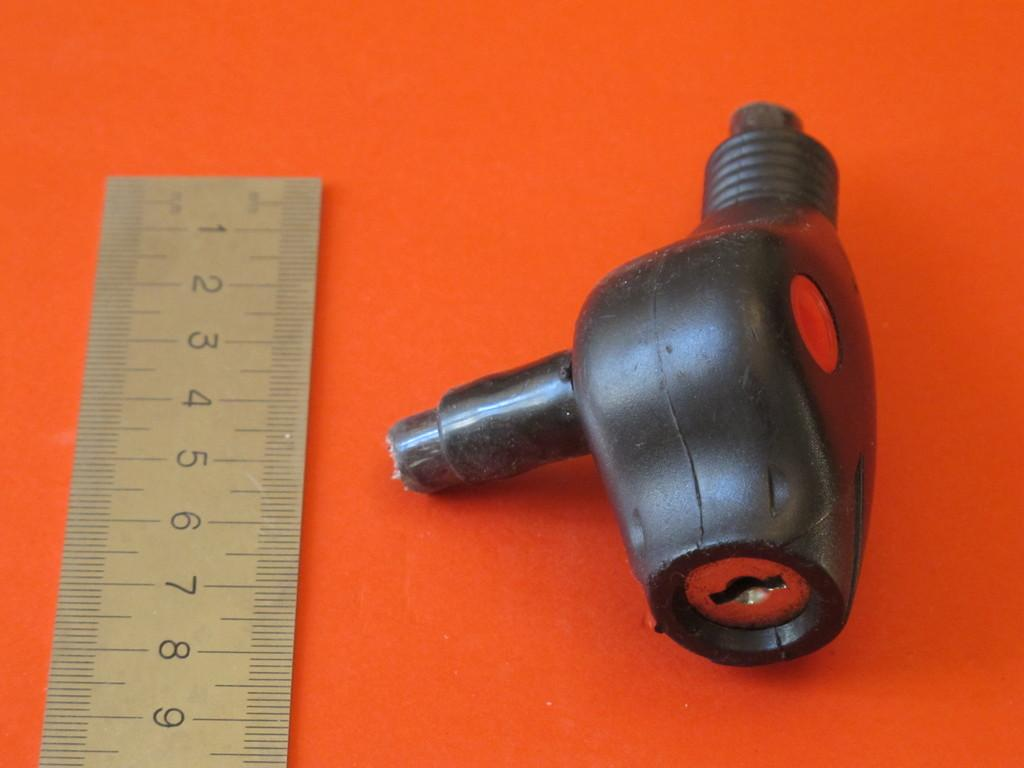Provide a one-sentence caption for the provided image. The lock is approximately eight centimeters in length. 